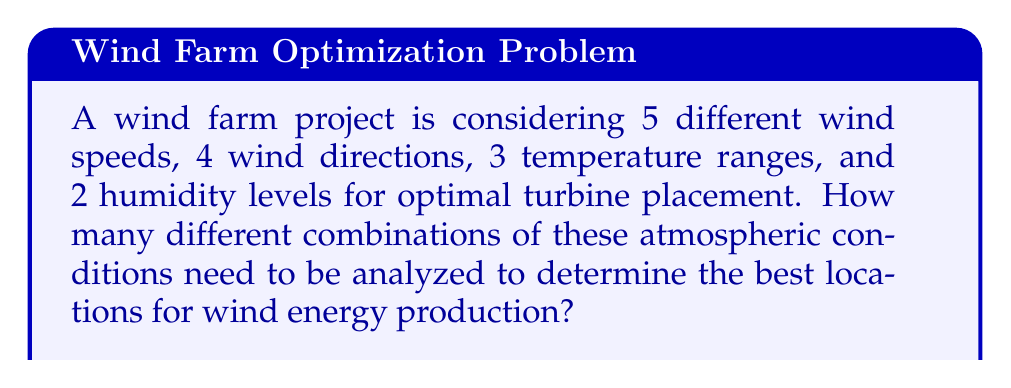Provide a solution to this math problem. To solve this problem, we'll use the multiplication principle of counting. This principle states that if we have a sequence of choices, and each choice is independent of the others, we multiply the number of possibilities for each choice to get the total number of combinations.

Let's break down the given information:
1. Wind speeds: 5 options
2. Wind directions: 4 options
3. Temperature ranges: 3 options
4. Humidity levels: 2 options

To find the total number of combinations, we multiply these numbers together:

$$ \text{Total combinations} = 5 \times 4 \times 3 \times 2 $$

$$ = 120 $$

This means that there are 120 different combinations of atmospheric conditions that need to be analyzed to determine the optimal locations for wind turbine placement.

Each of these 120 combinations represents a unique set of conditions that could potentially lead to optimal wind energy production. By analyzing each of these combinations, the meteorologist can provide comprehensive data to guide the placement of wind turbines for maximum energy output.
Answer: 120 combinations 